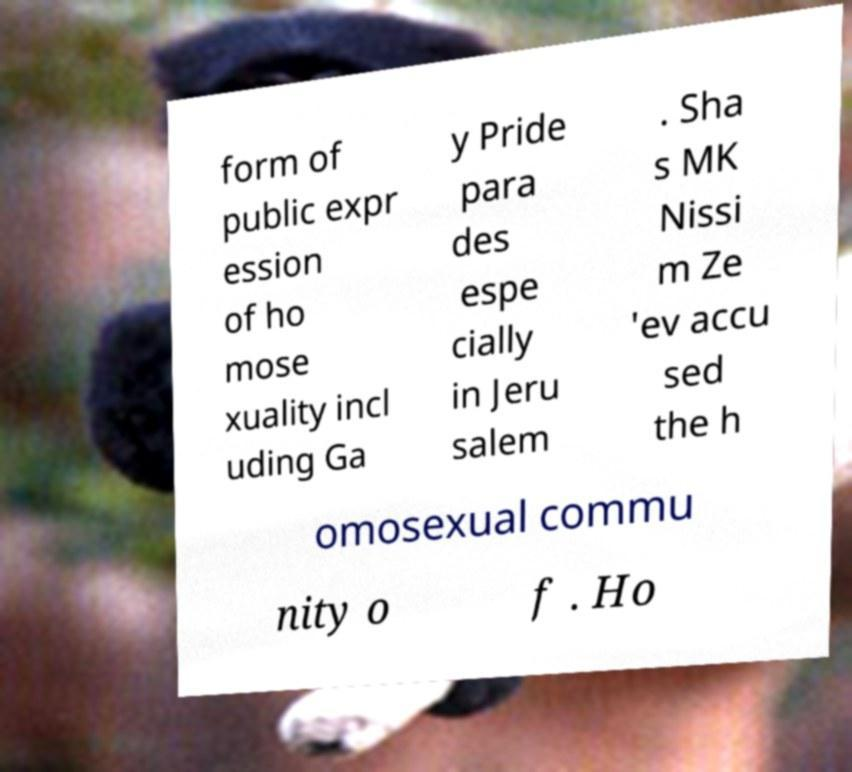Could you extract and type out the text from this image? form of public expr ession of ho mose xuality incl uding Ga y Pride para des espe cially in Jeru salem . Sha s MK Nissi m Ze 'ev accu sed the h omosexual commu nity o f . Ho 